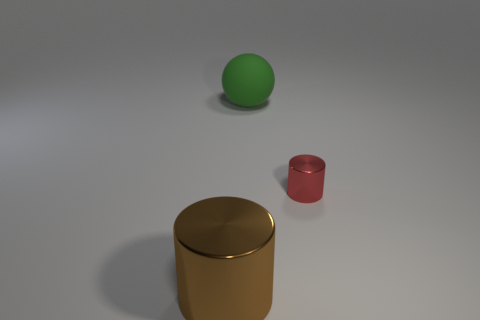Can you describe the lighting setup in this image? Certainly! The image features a soft and diffused lighting setup, which creates gentle shadows and subtle highlights on the objects. The light source seems to be positioned above the objects, resulting in soft shadow casting downwards onto the surface beneath them. 